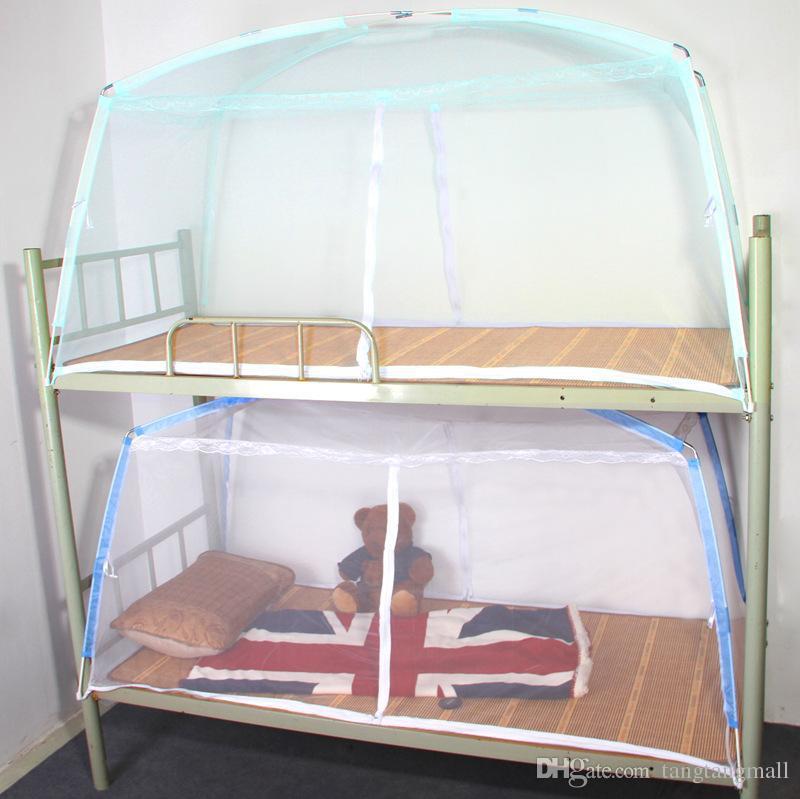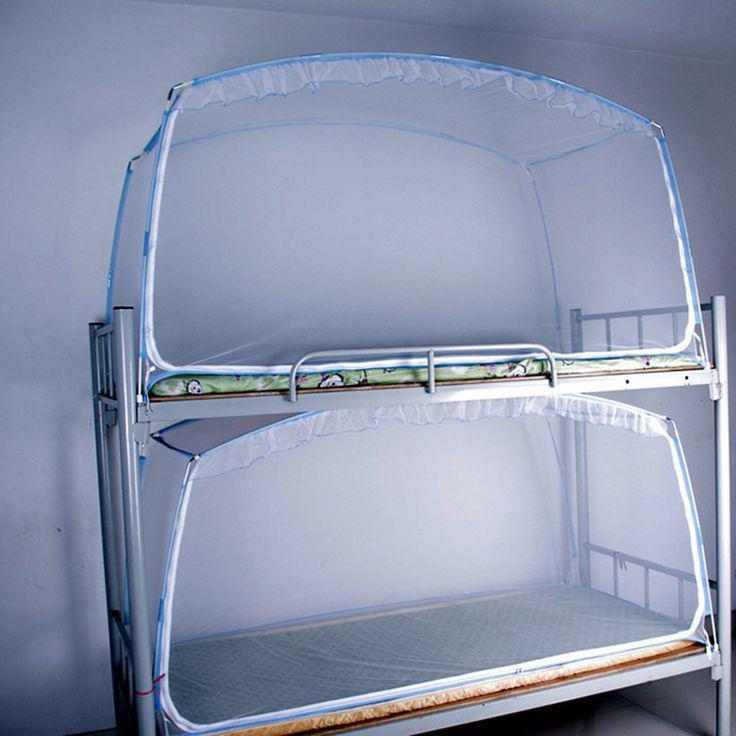The first image is the image on the left, the second image is the image on the right. Assess this claim about the two images: "An image shows a ceiling-suspended tent-shaped gauze canopy over bunk beds.". Correct or not? Answer yes or no. No. 